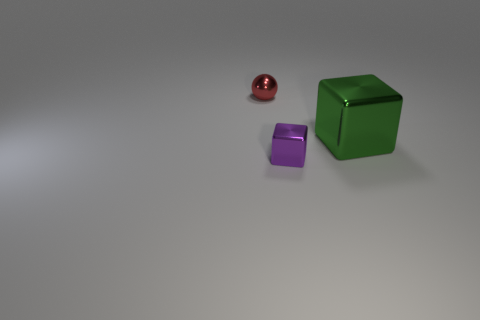Add 3 green metallic blocks. How many objects exist? 6 Subtract all tiny green cubes. Subtract all blocks. How many objects are left? 1 Add 1 green blocks. How many green blocks are left? 2 Add 3 tiny red objects. How many tiny red objects exist? 4 Subtract all green cubes. How many cubes are left? 1 Subtract 0 cyan balls. How many objects are left? 3 Subtract all balls. How many objects are left? 2 Subtract 1 spheres. How many spheres are left? 0 Subtract all purple cubes. Subtract all yellow spheres. How many cubes are left? 1 Subtract all yellow cylinders. How many purple cubes are left? 1 